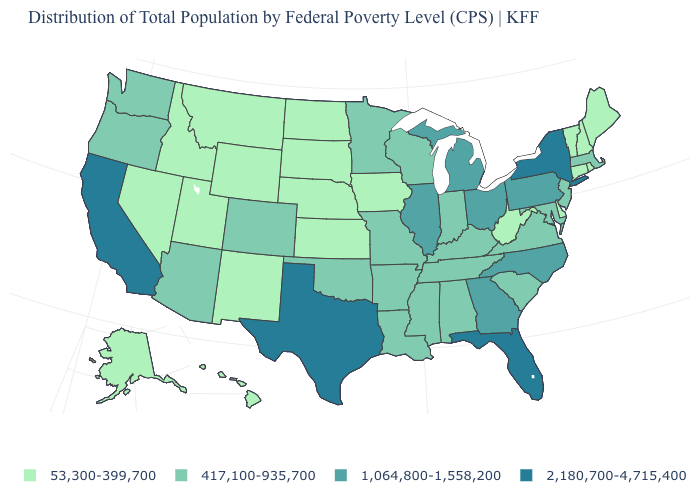Does the map have missing data?
Keep it brief. No. What is the value of Alaska?
Quick response, please. 53,300-399,700. What is the value of Pennsylvania?
Concise answer only. 1,064,800-1,558,200. What is the value of Georgia?
Answer briefly. 1,064,800-1,558,200. What is the value of Alaska?
Short answer required. 53,300-399,700. Name the states that have a value in the range 417,100-935,700?
Quick response, please. Alabama, Arizona, Arkansas, Colorado, Indiana, Kentucky, Louisiana, Maryland, Massachusetts, Minnesota, Mississippi, Missouri, New Jersey, Oklahoma, Oregon, South Carolina, Tennessee, Virginia, Washington, Wisconsin. Name the states that have a value in the range 417,100-935,700?
Keep it brief. Alabama, Arizona, Arkansas, Colorado, Indiana, Kentucky, Louisiana, Maryland, Massachusetts, Minnesota, Mississippi, Missouri, New Jersey, Oklahoma, Oregon, South Carolina, Tennessee, Virginia, Washington, Wisconsin. Name the states that have a value in the range 1,064,800-1,558,200?
Be succinct. Georgia, Illinois, Michigan, North Carolina, Ohio, Pennsylvania. Does Louisiana have the highest value in the USA?
Be succinct. No. Does Washington have the lowest value in the West?
Be succinct. No. How many symbols are there in the legend?
Keep it brief. 4. What is the value of Illinois?
Be succinct. 1,064,800-1,558,200. Among the states that border Indiana , which have the lowest value?
Answer briefly. Kentucky. Which states have the lowest value in the MidWest?
Keep it brief. Iowa, Kansas, Nebraska, North Dakota, South Dakota. Does the first symbol in the legend represent the smallest category?
Answer briefly. Yes. 